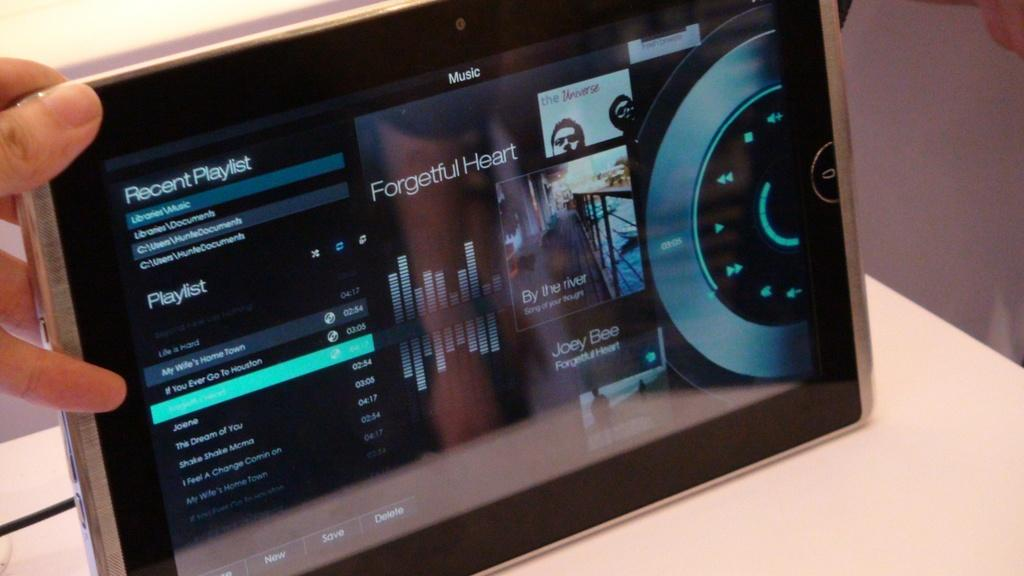What body part is visible in the image? There are fingers of a person in the image. What is the person doing with their fingers? The person is holding a device in the image. How many fish can be seen swimming near the person's toes in the image? There are no fish or toes visible in the image; it only shows fingers holding a device. 